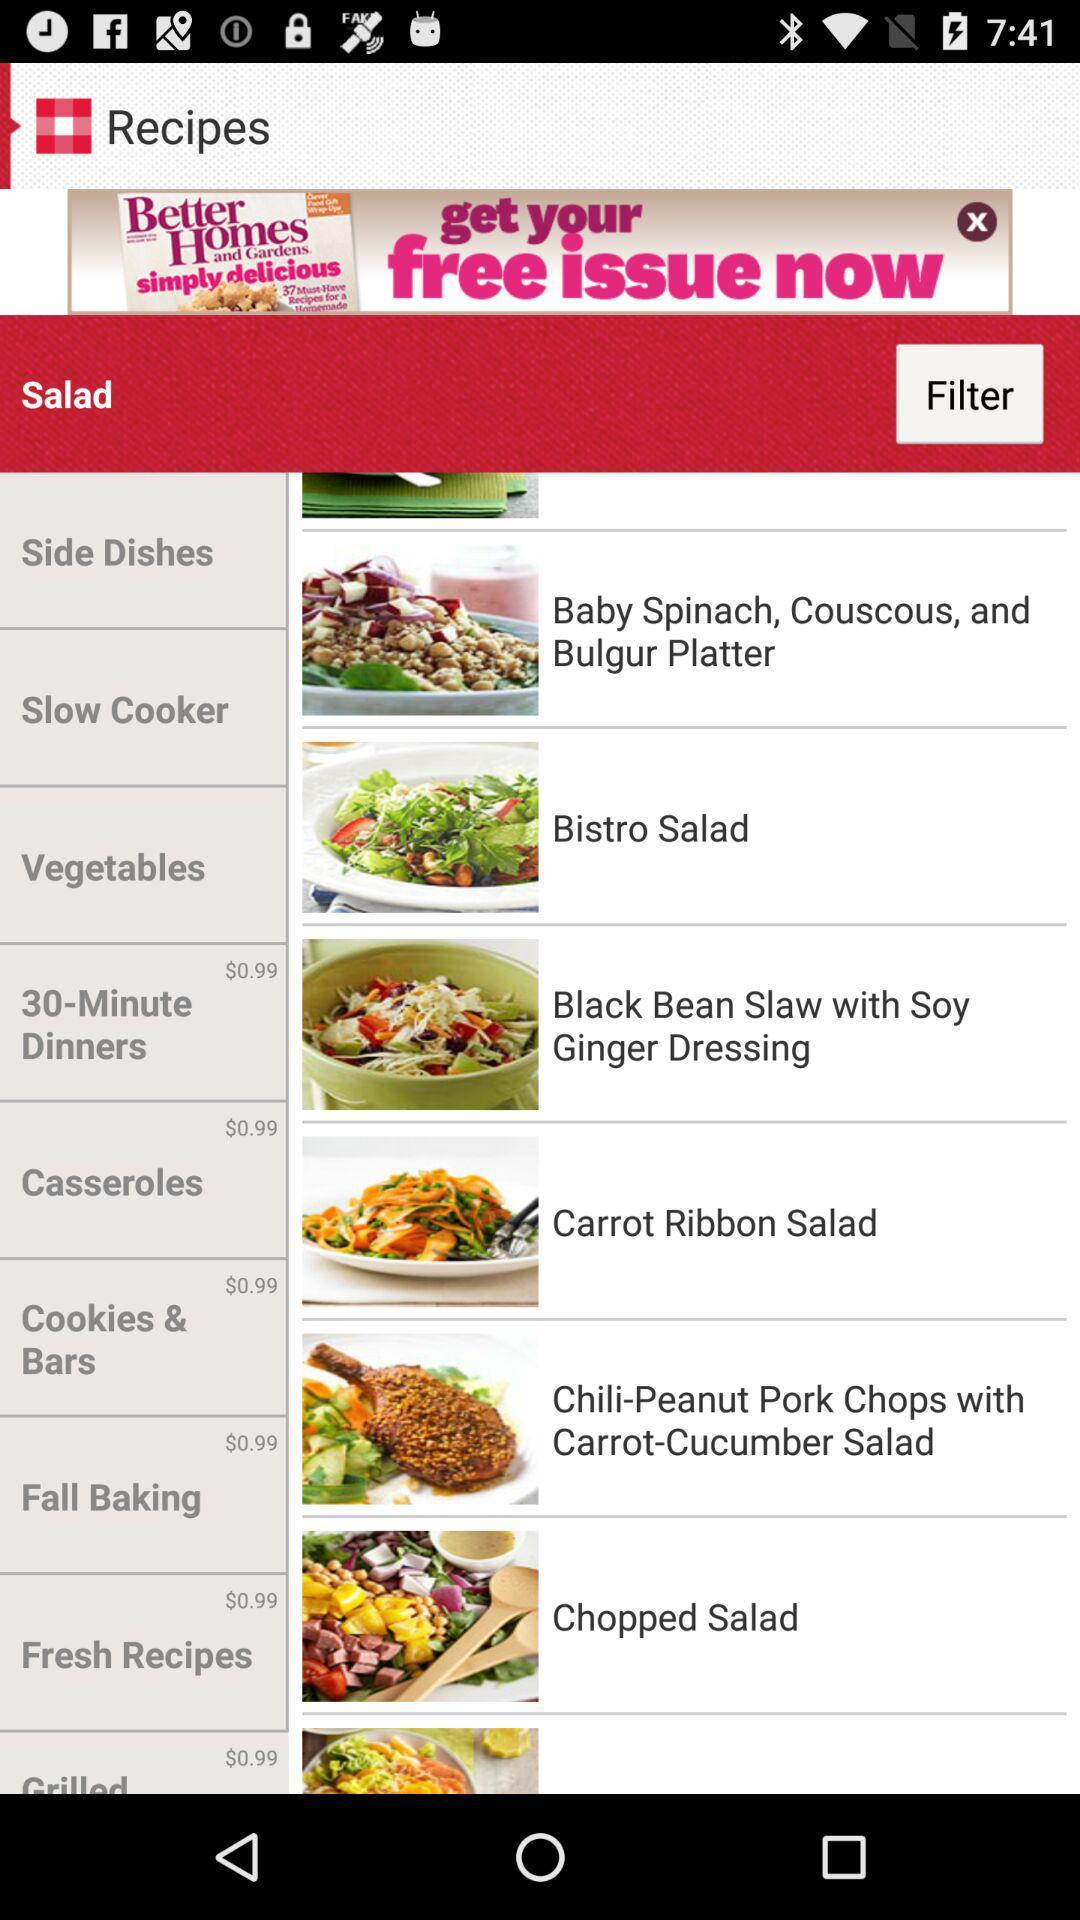What is the amount mentioned for "Cookies & Bars"? The amount mentioned for "Cookies & Bars" is $0.99. 